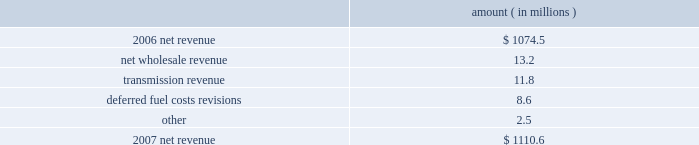Entergy arkansas , inc .
Management's financial discussion and analysis gross operating revenues and fuel and purchased power expenses gross operating revenues increased primarily due to : an increase of $ 114 million in gross wholesale revenue due to an increase in the average price of energy available for resale sales and an increase in sales to affiliated customers ; an increase of $ 106.1 million in production cost allocation rider revenues which became effective in july 2007 as a result of the system agreement proceedings .
As a result of the system agreement proceedings , entergy arkansas also has a corresponding increase in deferred fuel expense for payments to other entergy system companies such that there is no effect on net income .
Entergy arkansas makes payments over a seven-month period but collections from customers occur over a twelve-month period .
The production cost allocation rider is discussed in note 2 to the financial statements and the system agreement proceedings are referenced below under "federal regulation" ; and an increase of $ 58.9 million in fuel cost recovery revenues due to changes in the energy cost recovery rider effective april 2008 and september 2008 , partially offset by decreased usage .
The energy cost recovery rider filings are discussed in note 2 to the financial statements .
The increase was partially offset by a decrease of $ 14.6 million related to volume/weather , as discussed above .
Fuel and purchased power expenses increased primarily due to an increase of $ 106.1 million in deferred system agreement payments , as discussed above and an increase in the average market price of purchased power .
2007 compared to 2006 net revenue consists of operating revenues net of : 1 ) fuel , fuel-related expenses , and gas purchased for resale , 2 ) purchased power expenses , and 3 ) other regulatory credits .
Following is an analysis of the change in net revenue comparing 2007 to 2006 .
Amount ( in millions ) .
The net wholesale revenue variance is primarily due to lower wholesale revenues in the third quarter 2006 due to an october 2006 ferc order requiring entergy arkansas to make a refund to a coal plant co-owner resulting from a contract dispute , in addition to re-pricing revisions , retroactive to 2003 , of $ 5.9 million of purchased power agreements among entergy system companies as directed by the ferc .
The transmission revenue variance is primarily due to higher rates and the addition of new transmission customers in late 2006 .
The deferred fuel cost revisions variance is primarily due to the 2006 energy cost recovery true-up , made in the first quarter 2007 , which increased net revenue by $ 6.6 million .
Gross operating revenue and fuel and purchased power expenses gross operating revenues decreased primarily due to a decrease of $ 173.1 million in fuel cost recovery revenues due to a decrease in the energy cost recovery rider effective april 2007 .
The energy cost recovery rider is discussed in note 2 to the financial statements .
The decrease was partially offset by production cost allocation rider revenues of $ 124.1 million that became effective in july 2007 as a result of the system agreement proceedings .
As .
What is the net change in net revenue during 2007 for entergy arkansas , inc.? 
Computations: (1110.6 - 1074.5)
Answer: 36.1. Entergy arkansas , inc .
Management's financial discussion and analysis gross operating revenues and fuel and purchased power expenses gross operating revenues increased primarily due to : an increase of $ 114 million in gross wholesale revenue due to an increase in the average price of energy available for resale sales and an increase in sales to affiliated customers ; an increase of $ 106.1 million in production cost allocation rider revenues which became effective in july 2007 as a result of the system agreement proceedings .
As a result of the system agreement proceedings , entergy arkansas also has a corresponding increase in deferred fuel expense for payments to other entergy system companies such that there is no effect on net income .
Entergy arkansas makes payments over a seven-month period but collections from customers occur over a twelve-month period .
The production cost allocation rider is discussed in note 2 to the financial statements and the system agreement proceedings are referenced below under "federal regulation" ; and an increase of $ 58.9 million in fuel cost recovery revenues due to changes in the energy cost recovery rider effective april 2008 and september 2008 , partially offset by decreased usage .
The energy cost recovery rider filings are discussed in note 2 to the financial statements .
The increase was partially offset by a decrease of $ 14.6 million related to volume/weather , as discussed above .
Fuel and purchased power expenses increased primarily due to an increase of $ 106.1 million in deferred system agreement payments , as discussed above and an increase in the average market price of purchased power .
2007 compared to 2006 net revenue consists of operating revenues net of : 1 ) fuel , fuel-related expenses , and gas purchased for resale , 2 ) purchased power expenses , and 3 ) other regulatory credits .
Following is an analysis of the change in net revenue comparing 2007 to 2006 .
Amount ( in millions ) .
The net wholesale revenue variance is primarily due to lower wholesale revenues in the third quarter 2006 due to an october 2006 ferc order requiring entergy arkansas to make a refund to a coal plant co-owner resulting from a contract dispute , in addition to re-pricing revisions , retroactive to 2003 , of $ 5.9 million of purchased power agreements among entergy system companies as directed by the ferc .
The transmission revenue variance is primarily due to higher rates and the addition of new transmission customers in late 2006 .
The deferred fuel cost revisions variance is primarily due to the 2006 energy cost recovery true-up , made in the first quarter 2007 , which increased net revenue by $ 6.6 million .
Gross operating revenue and fuel and purchased power expenses gross operating revenues decreased primarily due to a decrease of $ 173.1 million in fuel cost recovery revenues due to a decrease in the energy cost recovery rider effective april 2007 .
The energy cost recovery rider is discussed in note 2 to the financial statements .
The decrease was partially offset by production cost allocation rider revenues of $ 124.1 million that became effective in july 2007 as a result of the system agreement proceedings .
As .
What percent of the net change in revenue between 2007 and 2008 was due to transmission revenue? 
Computations: (11.8 / (1074.5 - 1110.6))
Answer: -0.32687. Entergy arkansas , inc .
Management's financial discussion and analysis gross operating revenues and fuel and purchased power expenses gross operating revenues increased primarily due to : an increase of $ 114 million in gross wholesale revenue due to an increase in the average price of energy available for resale sales and an increase in sales to affiliated customers ; an increase of $ 106.1 million in production cost allocation rider revenues which became effective in july 2007 as a result of the system agreement proceedings .
As a result of the system agreement proceedings , entergy arkansas also has a corresponding increase in deferred fuel expense for payments to other entergy system companies such that there is no effect on net income .
Entergy arkansas makes payments over a seven-month period but collections from customers occur over a twelve-month period .
The production cost allocation rider is discussed in note 2 to the financial statements and the system agreement proceedings are referenced below under "federal regulation" ; and an increase of $ 58.9 million in fuel cost recovery revenues due to changes in the energy cost recovery rider effective april 2008 and september 2008 , partially offset by decreased usage .
The energy cost recovery rider filings are discussed in note 2 to the financial statements .
The increase was partially offset by a decrease of $ 14.6 million related to volume/weather , as discussed above .
Fuel and purchased power expenses increased primarily due to an increase of $ 106.1 million in deferred system agreement payments , as discussed above and an increase in the average market price of purchased power .
2007 compared to 2006 net revenue consists of operating revenues net of : 1 ) fuel , fuel-related expenses , and gas purchased for resale , 2 ) purchased power expenses , and 3 ) other regulatory credits .
Following is an analysis of the change in net revenue comparing 2007 to 2006 .
Amount ( in millions ) .
The net wholesale revenue variance is primarily due to lower wholesale revenues in the third quarter 2006 due to an october 2006 ferc order requiring entergy arkansas to make a refund to a coal plant co-owner resulting from a contract dispute , in addition to re-pricing revisions , retroactive to 2003 , of $ 5.9 million of purchased power agreements among entergy system companies as directed by the ferc .
The transmission revenue variance is primarily due to higher rates and the addition of new transmission customers in late 2006 .
The deferred fuel cost revisions variance is primarily due to the 2006 energy cost recovery true-up , made in the first quarter 2007 , which increased net revenue by $ 6.6 million .
Gross operating revenue and fuel and purchased power expenses gross operating revenues decreased primarily due to a decrease of $ 173.1 million in fuel cost recovery revenues due to a decrease in the energy cost recovery rider effective april 2007 .
The energy cost recovery rider is discussed in note 2 to the financial statements .
The decrease was partially offset by production cost allocation rider revenues of $ 124.1 million that became effective in july 2007 as a result of the system agreement proceedings .
As .
What is the percent change in net revenue between 2006 and 2007? 
Computations: ((1074.5 - 1110.6) / 1110.6)
Answer: -0.0325. 